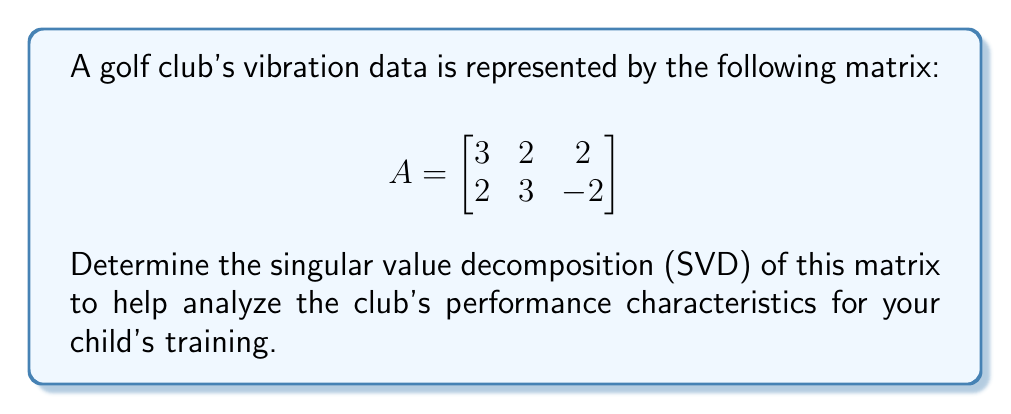Can you answer this question? To find the singular value decomposition (SVD) of matrix A, we need to find matrices U, Σ, and V such that A = UΣV^T.

Step 1: Calculate A^T A and AA^T
$$A^T A = \begin{bmatrix}
3 & 2 \\
2 & 3 \\
2 & -2
\end{bmatrix} \begin{bmatrix}
3 & 2 & 2 \\
2 & 3 & -2
\end{bmatrix} = \begin{bmatrix}
17 & 12 & 2 \\
12 & 13 & -2 \\
2 & -2 & 8
\end{bmatrix}$$

$$AA^T = \begin{bmatrix}
3 & 2 & 2 \\
2 & 3 & -2
\end{bmatrix} \begin{bmatrix}
3 & 2 \\
2 & 3 \\
2 & -2
\end{bmatrix} = \begin{bmatrix}
17 & 12 \\
12 & 17
\end{bmatrix}$$

Step 2: Find eigenvalues of A^T A (which are the squares of singular values)
Characteristic equation: $\det(A^T A - \lambda I) = 0$
$$(17-\lambda)(13-\lambda)(8-\lambda) - 12^2(8-\lambda) - 2^2(13-\lambda) - (-2)^2(17-\lambda) + 2 \cdot 12 \cdot 2 = 0$$
Solving this equation gives us: $\lambda_1 = 25, \lambda_2 = 9, \lambda_3 = 4$

Step 3: Calculate singular values
$\sigma_1 = \sqrt{25} = 5, \sigma_2 = 3, \sigma_3 = 2$

Step 4: Find right singular vectors (eigenvectors of A^T A)
For $\lambda_1 = 25$: $v_1 = [0.6, 0.8, 0]^T$
For $\lambda_2 = 9$: $v_2 = [-0.8, 0.6, 0]^T$
For $\lambda_3 = 4$: $v_3 = [0, 0, 1]^T$

Step 5: Find left singular vectors
$u_1 = \frac{1}{\sigma_1}Av_1 = [0.6, 0.8]^T$
$u_2 = \frac{1}{\sigma_2}Av_2 = [-0.8, 0.6]^T$

Step 6: Construct U, Σ, and V matrices
$$U = \begin{bmatrix}
0.6 & -0.8 \\
0.8 & 0.6
\end{bmatrix}$$

$$\Sigma = \begin{bmatrix}
5 & 0 & 0 \\
0 & 3 & 0
\end{bmatrix}$$

$$V = \begin{bmatrix}
0.6 & -0.8 & 0 \\
0.8 & 0.6 & 0 \\
0 & 0 & 1
\end{bmatrix}$$
Answer: $A = U\Sigma V^T$, where
$U = \begin{bmatrix}0.6 & -0.8 \\ 0.8 & 0.6\end{bmatrix}$,
$\Sigma = \begin{bmatrix}5 & 0 & 0 \\ 0 & 3 & 0\end{bmatrix}$,
$V = \begin{bmatrix}0.6 & -0.8 & 0 \\ 0.8 & 0.6 & 0 \\ 0 & 0 & 1\end{bmatrix}$ 